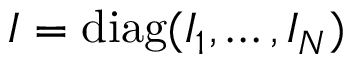Convert formula to latex. <formula><loc_0><loc_0><loc_500><loc_500>I = d i a g ( I _ { 1 } , \dots , I _ { N } )</formula> 